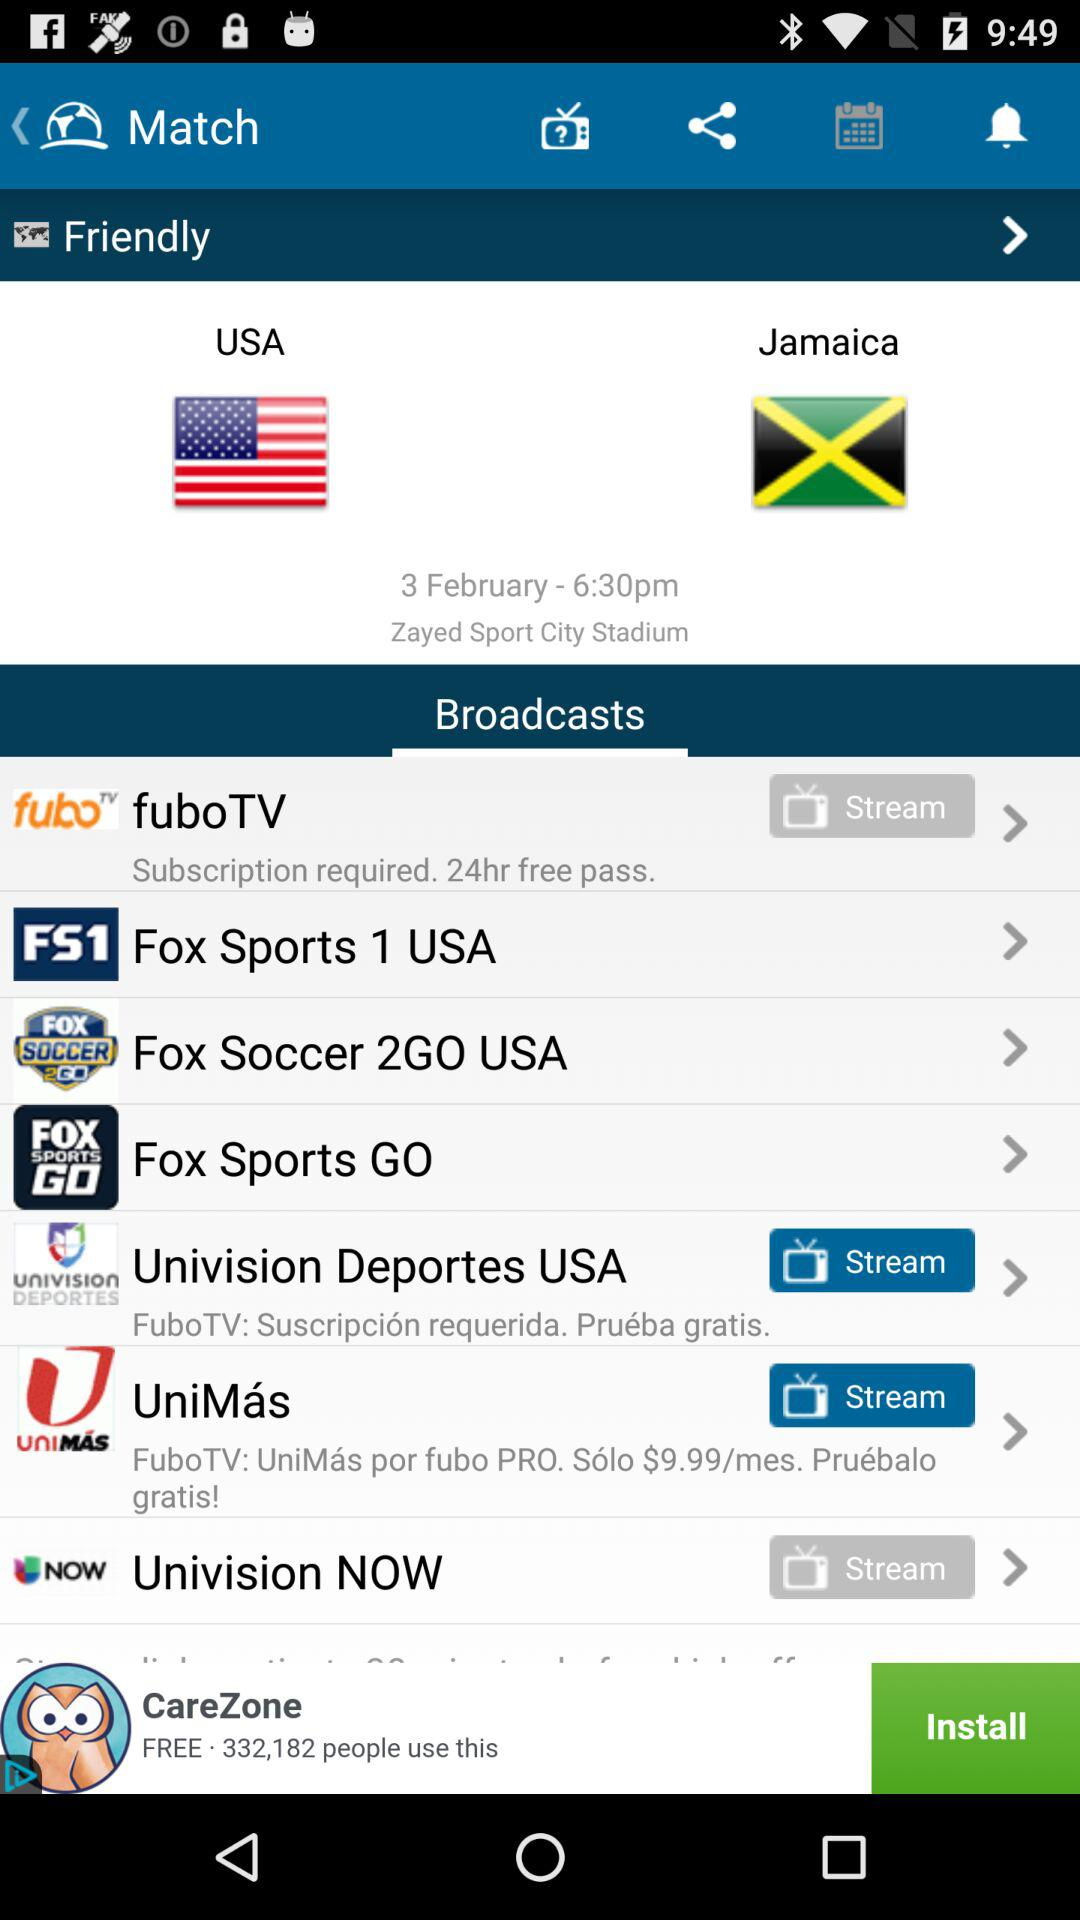Which country is competing in the match? The countries competing in the match are the USA and Jamaica. 